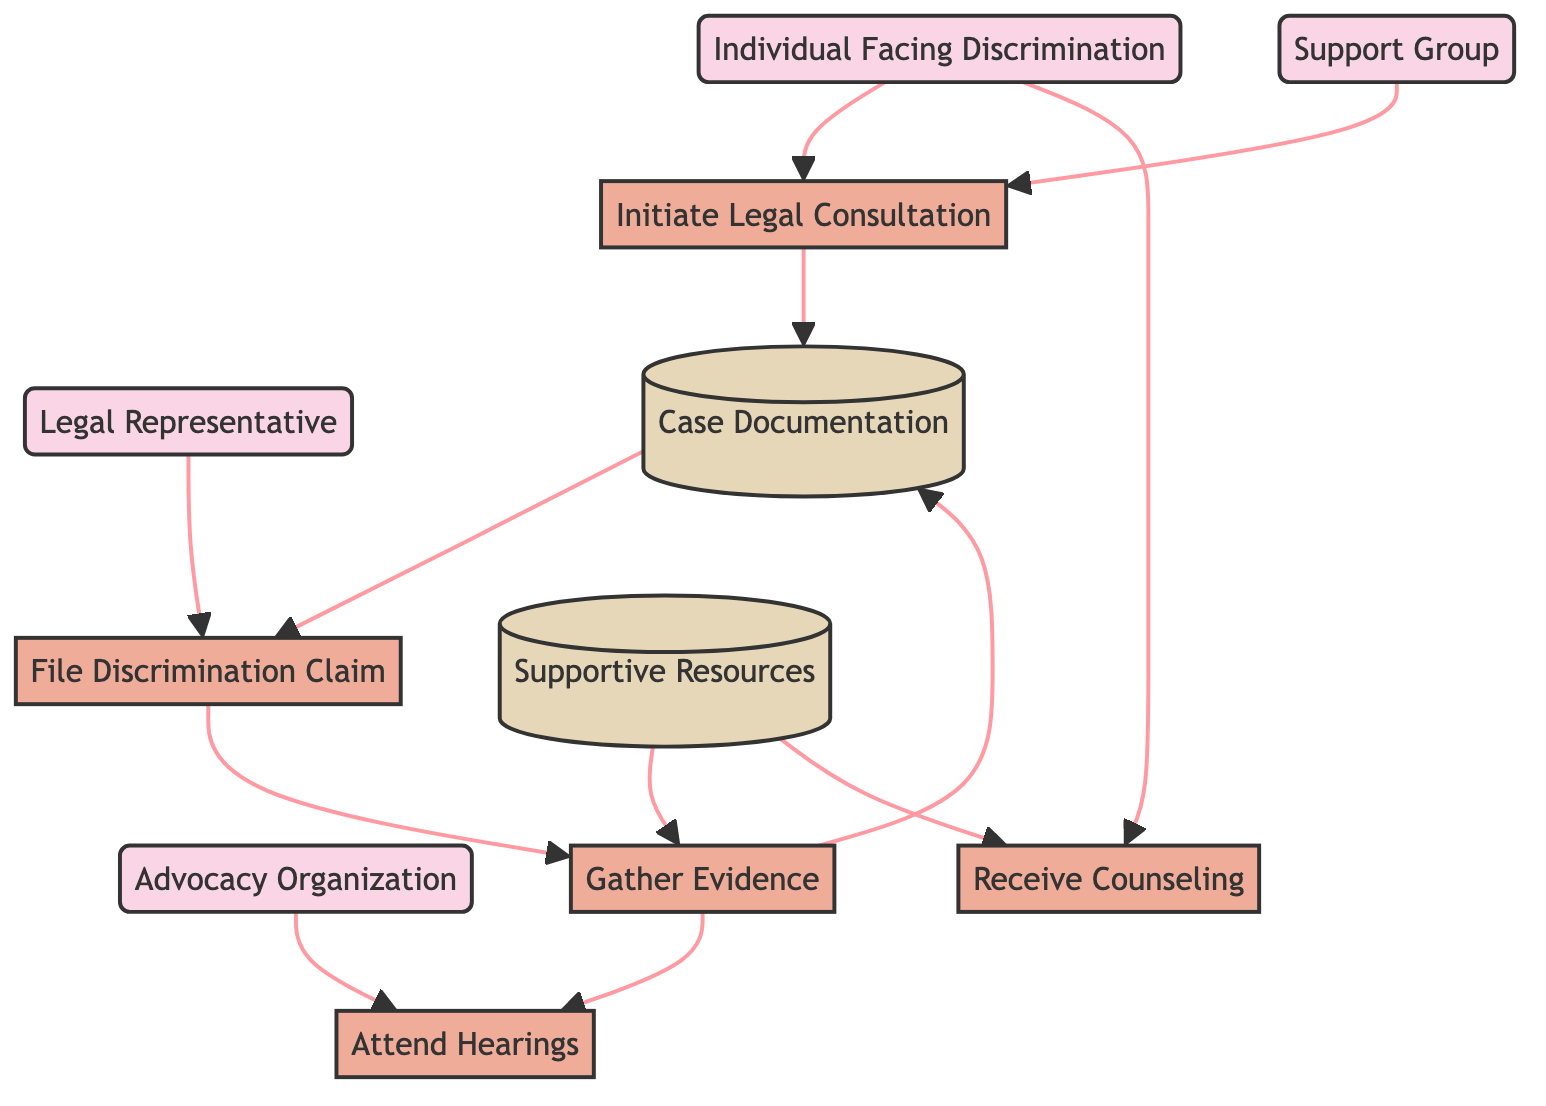What is the first process an individual takes in the diagram? The diagram shows that the first process is "Initiate Legal Consultation," which follows the external entity "Individual Facing Discrimination."
Answer: Initiate Legal Consultation How many external entities are represented in the diagram? By counting the distinct external entities listed in the diagram, we find there are four: "Individual Facing Discrimination," "Support Group," "Legal Representative," and "Advocacy Organization."
Answer: 4 Which process is connected to both "Gather Evidence" and "Attend Hearings"? Analyzing the connections, "Gather Evidence" leads directly to "Attend Hearings," while "Gather Evidence" also receives input from "Supportive Resources." Therefore, "Gather Evidence" serves as a connecting process.
Answer: Gather Evidence What stores documentation related to the discrimination case? The diagram indicates that "Case Documentation" is the designated data store containing records of incidents and evidence related to the discrimination case.
Answer: Case Documentation Which external entity provides emotional support to individuals? The diagram shows "Support Group" as the external entity that provides emotional and initial practical support to the individual facing discrimination.
Answer: Support Group What process must immediately follow the "Initiate Legal Consultation"? Following the process "Initiate Legal Consultation," which collects information on the legal case, the next step in the flow is "File Discrimination Claim."
Answer: File Discrimination Claim What resource must be gathered to support the case? The process "Gather Evidence" indicates that relevant information and documentation must be collected to support the discrimination case.
Answer: Evidence Which process allows the individual to receive emotional support? The diagram illustrates that "Receive Counseling" is the process through which the individual can access professional emotional and psychological support services.
Answer: Receive Counseling How many data stores are present in this diagram? The diagram shows that there are two data stores: "Case Documentation" and "Supportive Resources." Counting these provides us with the answer.
Answer: 2 